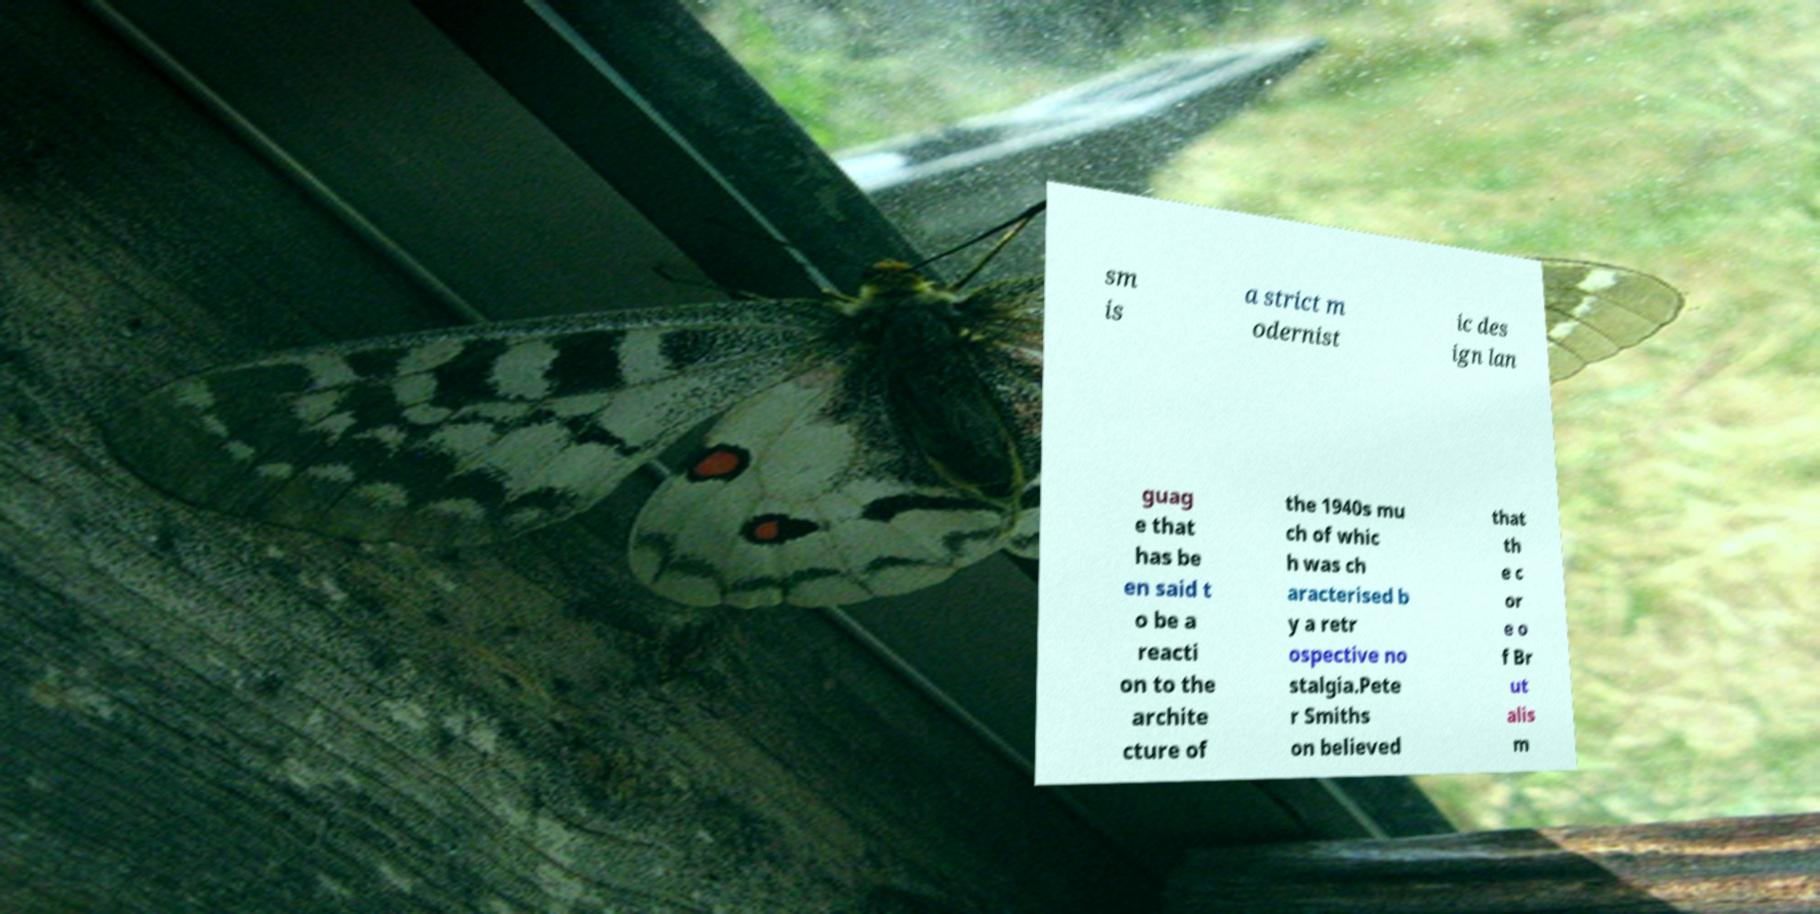Please read and relay the text visible in this image. What does it say? sm is a strict m odernist ic des ign lan guag e that has be en said t o be a reacti on to the archite cture of the 1940s mu ch of whic h was ch aracterised b y a retr ospective no stalgia.Pete r Smiths on believed that th e c or e o f Br ut alis m 